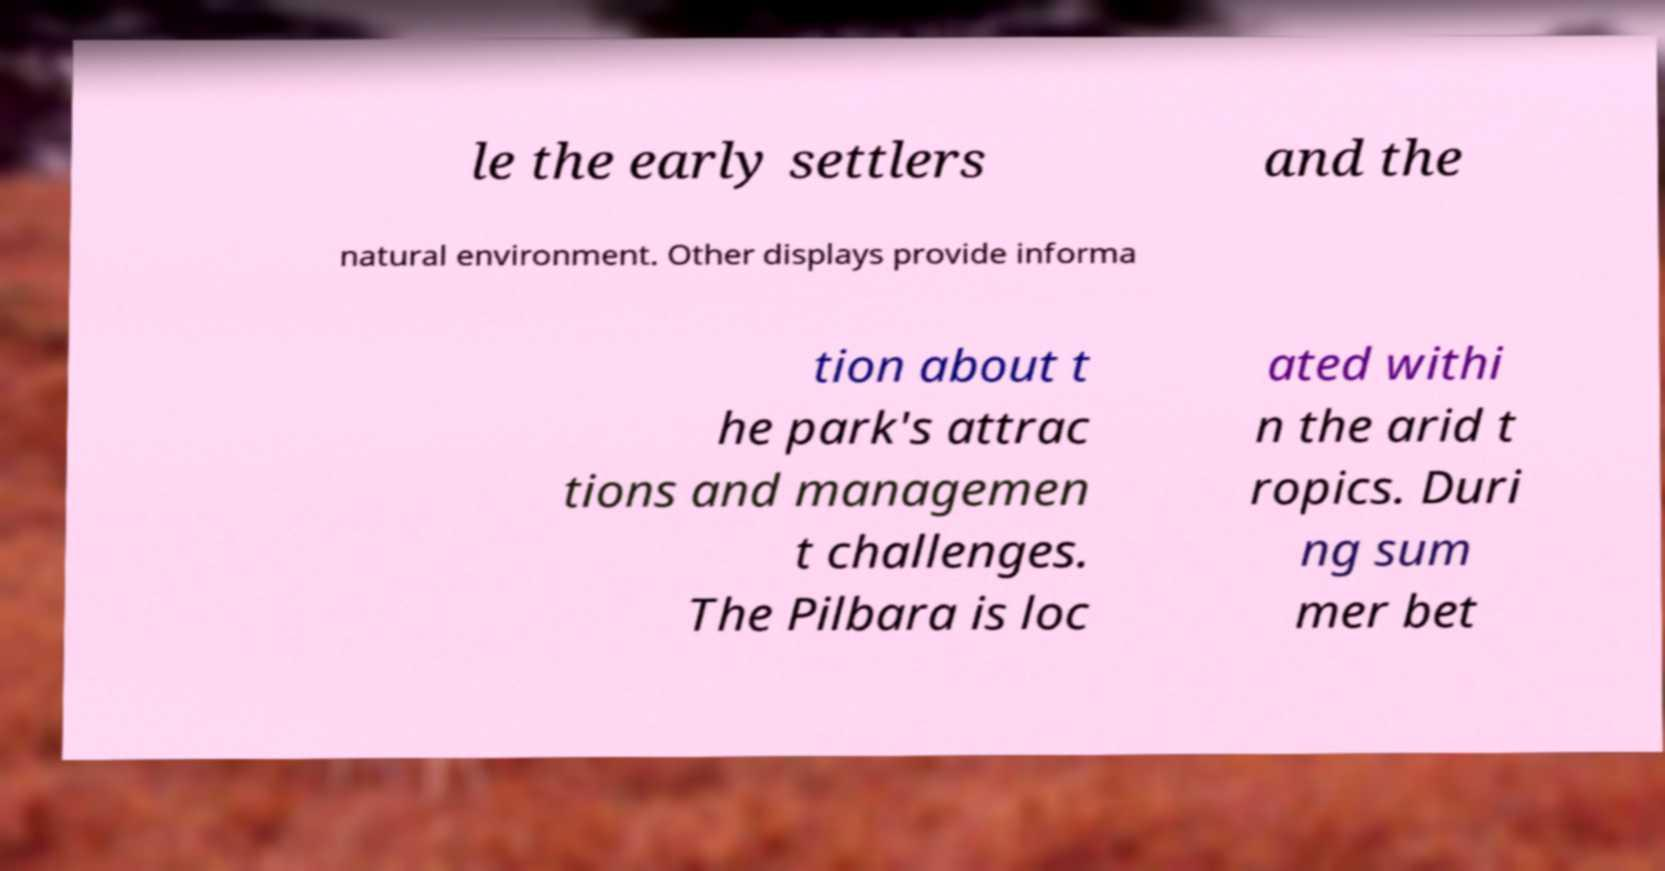Could you assist in decoding the text presented in this image and type it out clearly? le the early settlers and the natural environment. Other displays provide informa tion about t he park's attrac tions and managemen t challenges. The Pilbara is loc ated withi n the arid t ropics. Duri ng sum mer bet 